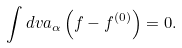Convert formula to latex. <formula><loc_0><loc_0><loc_500><loc_500>\int d v a _ { \alpha } \left ( f - f ^ { ( 0 ) } \right ) = 0 .</formula> 